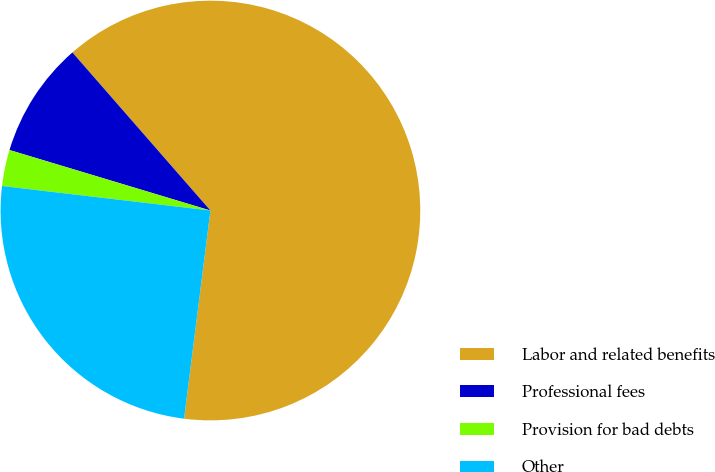<chart> <loc_0><loc_0><loc_500><loc_500><pie_chart><fcel>Labor and related benefits<fcel>Professional fees<fcel>Provision for bad debts<fcel>Other<nl><fcel>63.42%<fcel>8.92%<fcel>2.79%<fcel>24.86%<nl></chart> 